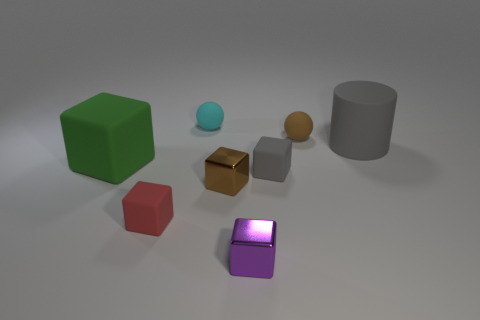What color is the matte block that is to the left of the small red matte cube to the left of the small brown thing that is in front of the gray cylinder? green 